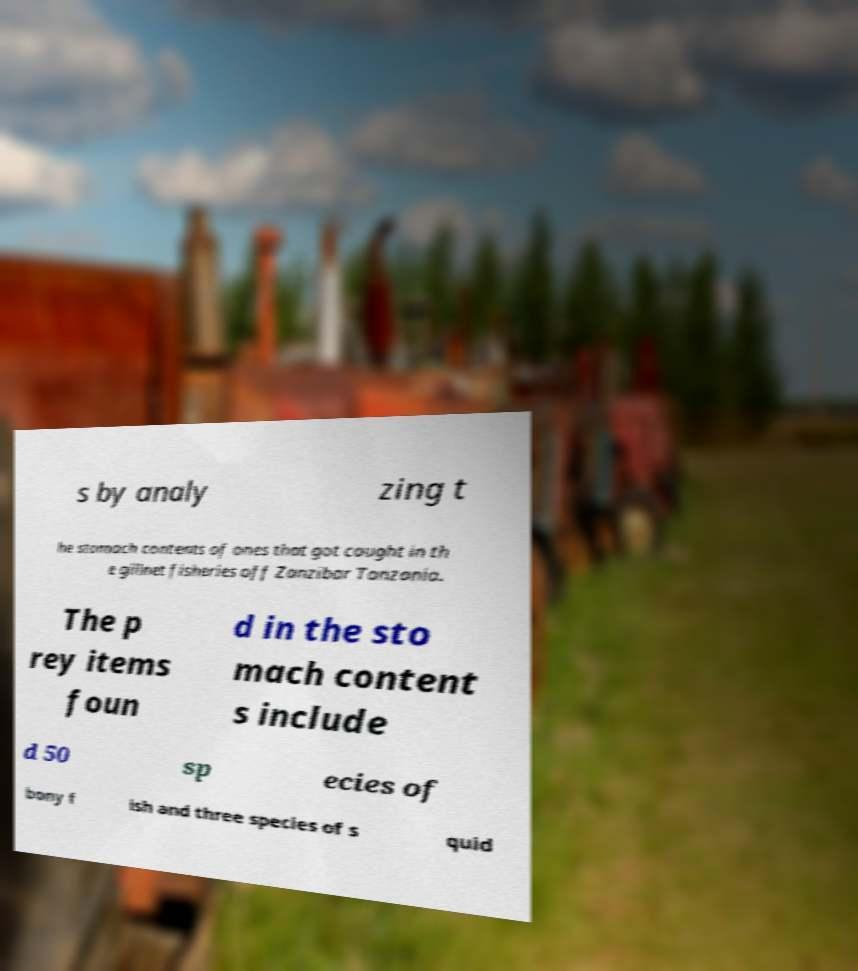Could you assist in decoding the text presented in this image and type it out clearly? s by analy zing t he stomach contents of ones that got caught in th e gillnet fisheries off Zanzibar Tanzania. The p rey items foun d in the sto mach content s include d 50 sp ecies of bony f ish and three species of s quid 